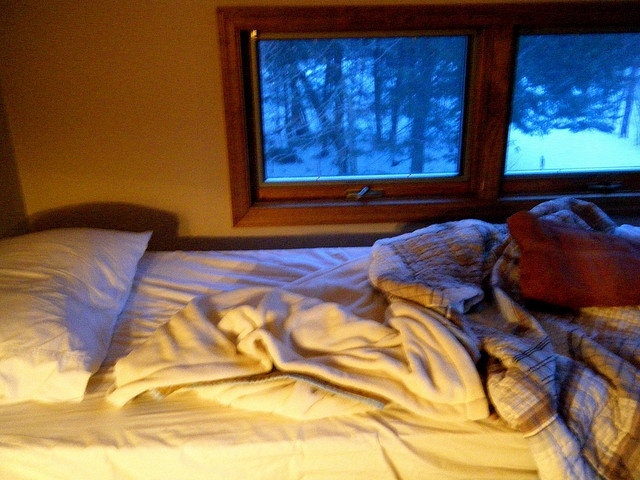Describe the objects in this image and their specific colors. I can see a bed in maroon, khaki, tan, gold, and black tones in this image. 